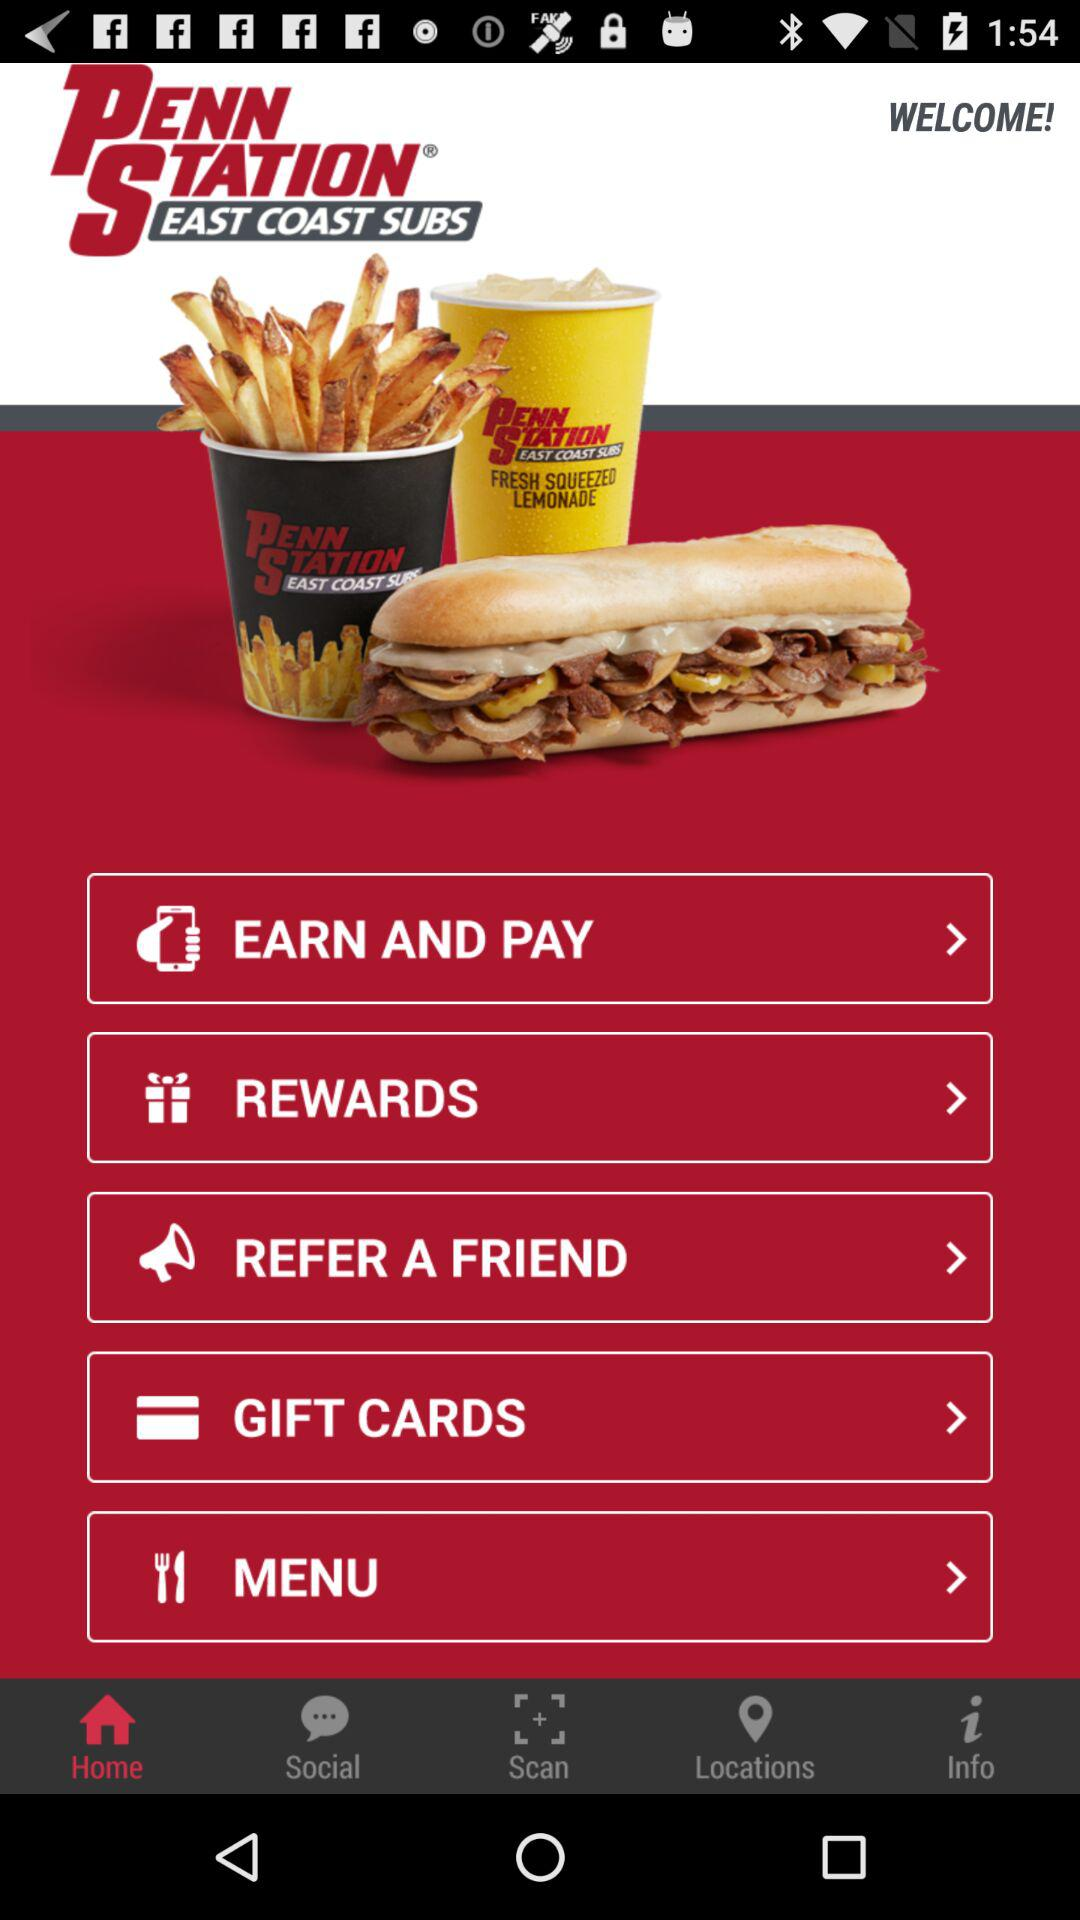Which is the selected tab? The selected tab is "Home". 